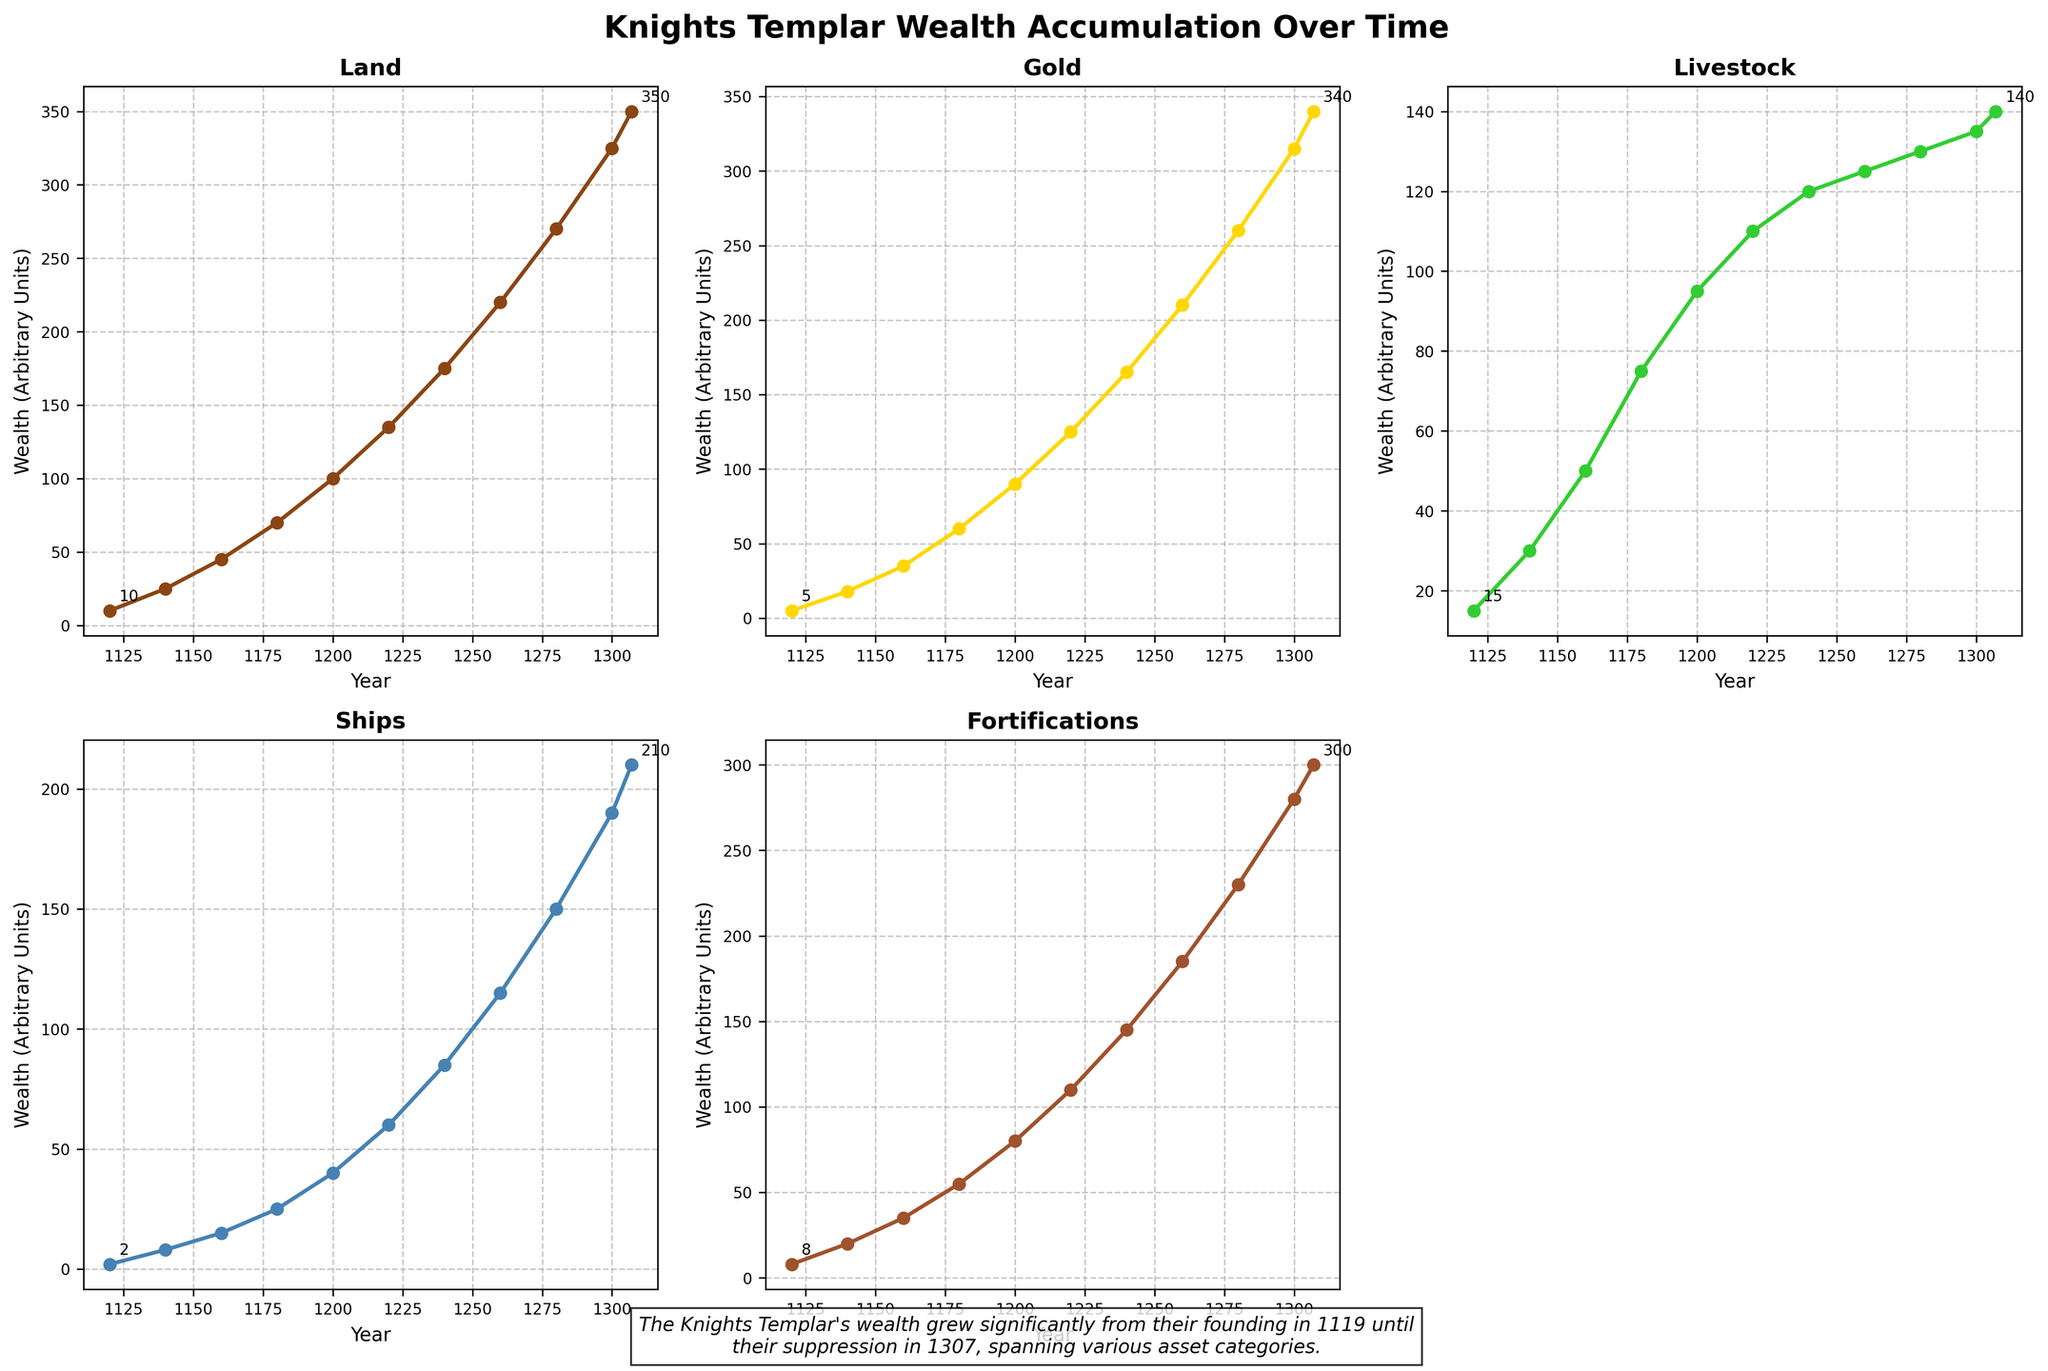How does the total wealth from Land and Gold in 1200 compare to the total wealth from Land and Livestock in 1160? First, sum the wealth of Land and Gold in 1200: 100 (Land) + 90 (Gold) = 190. Then sum the wealth of Land and Livestock in 1160: 45 (Land) + 50 (Livestock) = 95. Comparing the two sums: 190 (in 1200) is greater than 95 (in 1160).
Answer: Greater Which asset category shows the steepest increase in wealth from 1180 to 1200? Evaluate the change in wealth for each category between 1180 and 1200: Land (100-70=30), Gold (90-60=30), Livestock (95-75=20), Ships (40-25=15), Fortifications (80-55=25). Both Land and Gold have the highest increase of 30.
Answer: Land and Gold Among the categories presented, which has the lowest overall wealth in 1307? From the 1307 data points: Land (350), Gold (340), Livestock (140), Ships (210), Fortifications (300). Livestock has the lowest value, 140.
Answer: Livestock By how much did the wealth in Fortifications increase from 1240 to 1280? Subtract Fortifications wealth in 1240 from that in 1280: 230 - 145 = 85. The wealth increases by 85 units.
Answer: 85 Which categories show a wealth greater than 200 units in 1300? Evaluate the 1300 data: Land (325), Gold (315), Livestock (135), Ships (190), Fortifications (280). Land, Gold, and Fortifications have values greater than 200 units.
Answer: Land, Gold, and Fortifications What is the average wealth accumulated in Ships between 1160 and 1200? First, sum the wealth values between the years from 1160 to 1200: 15 (1160) + 25 (1180) + 40 (1200) = 80. Then, divide by the number of values (3): 80 / 3 ≈ 26.67.
Answer: 26.67 In which category did the wealth exceed 150 units first? Looking at each category's data:
Land exceeds 150 in 1240,
Gold exceeds 150 in 1240,
Livestock never exceeds 150,
Ships never exceed 150,
Fortifications exceed 150 in 1260.
Both Land and Gold reached more than 150 first in 1240.
Answer: Land and Gold Which category's wealth remained below 120 units throughout the period shown? The only category with values below 120 the entire period is Ships: maximum wealth was 115 in 1260, thus always below 120.
Answer: Ships 